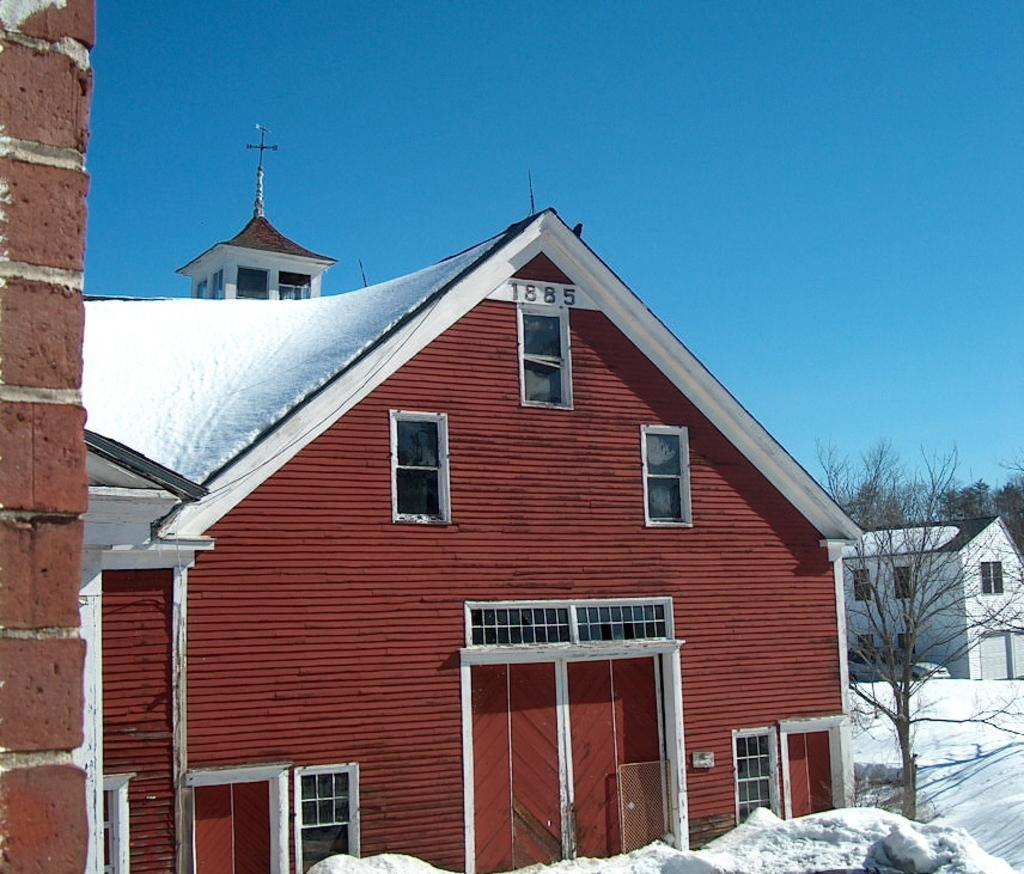What is located in the foreground of the image? There is a house, snow, and a tree in the foreground of the image. What can be seen in the background of the image? There is another house, trees, and the sky visible in the background of the image. How many houses are present in the image? There are two houses in the image, one in the foreground and one in the background. What type of weather is depicted in the image? The presence of snow in the foreground suggests that it is a snowy day. Can you see any bones sticking out of the snow in the image? There are no bones visible in the image; it only shows a house, snow, and a tree in the foreground, and another house, trees, and the sky in the background. --- Facts: 1. There is a person holding a book in the image. 2. The person is sitting on a chair. 3. There is a table next to the chair. 4. The table has a lamp on it. 5. The background of the image is a room with a window. Absurd Topics: parrot, ocean, bicycle Conversation: What is the person in the image holding? The person is holding a book in the image. What is the person sitting on? The person is sitting on a chair. What is located next to the chair? There is a table next to the chair. What is on the table? The table has a lamp on it. What can be seen in the background of the image? The background of the image is a room with a window. Reasoning: Let's think step by step in order to produce the conversation. We start by identifying the main subject in the image, which is the person holding a book. Then, we expand the conversation to include other items that are also visible, such as the chair, table, lamp, and the room with a window. Each question is designed to elicit a specific detail about the image that is known from the provided facts. Absurd Question/Answer: Can you see a parrot flying near the window in the image? There is no parrot visible in the image; it only shows a person holding a book, sitting on a chair, a table with a lamp, and a room with a window. 